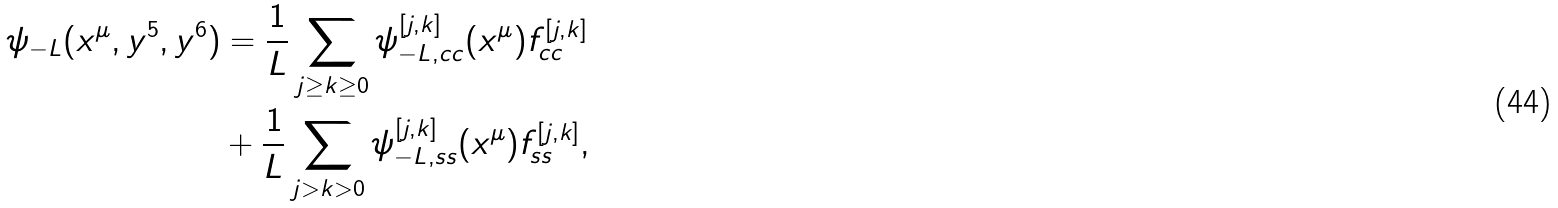<formula> <loc_0><loc_0><loc_500><loc_500>\psi _ { - L } ( x ^ { \mu } , y ^ { 5 } , y ^ { 6 } ) & = \frac { 1 } { L } \sum _ { j \geq k \geq 0 } \psi _ { - L , c c } ^ { [ j , k ] } ( x ^ { \mu } ) f _ { c c } ^ { [ j , k ] } \\ & + \frac { 1 } { L } \sum _ { j > k > 0 } \psi _ { - L , s s } ^ { [ j , k ] } ( x ^ { \mu } ) f _ { s s } ^ { [ j , k ] } ,</formula> 